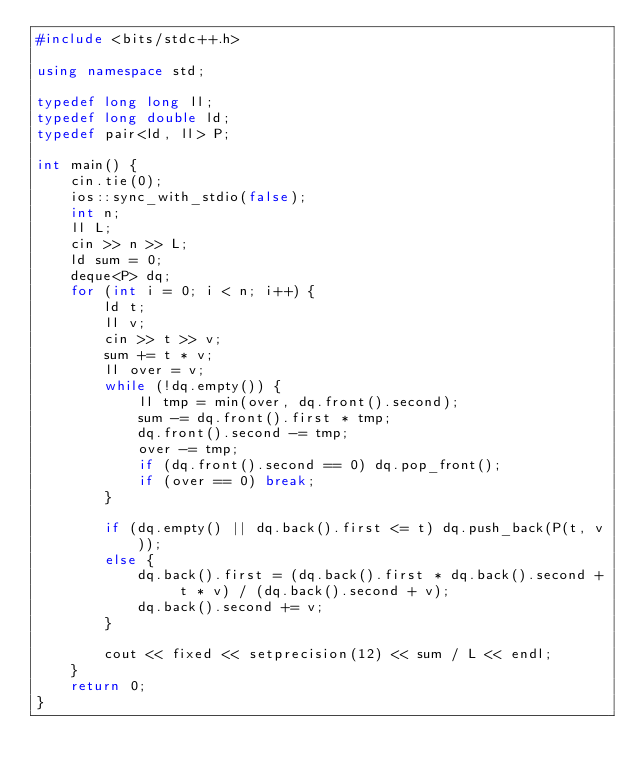Convert code to text. <code><loc_0><loc_0><loc_500><loc_500><_C++_>#include <bits/stdc++.h>

using namespace std;

typedef long long ll;
typedef long double ld;
typedef pair<ld, ll> P;

int main() {
	cin.tie(0);
	ios::sync_with_stdio(false);
	int n;
	ll L;
	cin >> n >> L;
	ld sum = 0;
	deque<P> dq;
	for (int i = 0; i < n; i++) {
		ld t;
		ll v;
		cin >> t >> v;
		sum += t * v;
		ll over = v;
		while (!dq.empty()) {
			ll tmp = min(over, dq.front().second);
			sum -= dq.front().first * tmp;
			dq.front().second -= tmp;
			over -= tmp;
			if (dq.front().second == 0) dq.pop_front();
			if (over == 0) break;
		}

		if (dq.empty() || dq.back().first <= t) dq.push_back(P(t, v));
		else {
			dq.back().first = (dq.back().first * dq.back().second + t * v) / (dq.back().second + v);
			dq.back().second += v;
		}

		cout << fixed << setprecision(12) << sum / L << endl;
	}
	return 0;
}</code> 